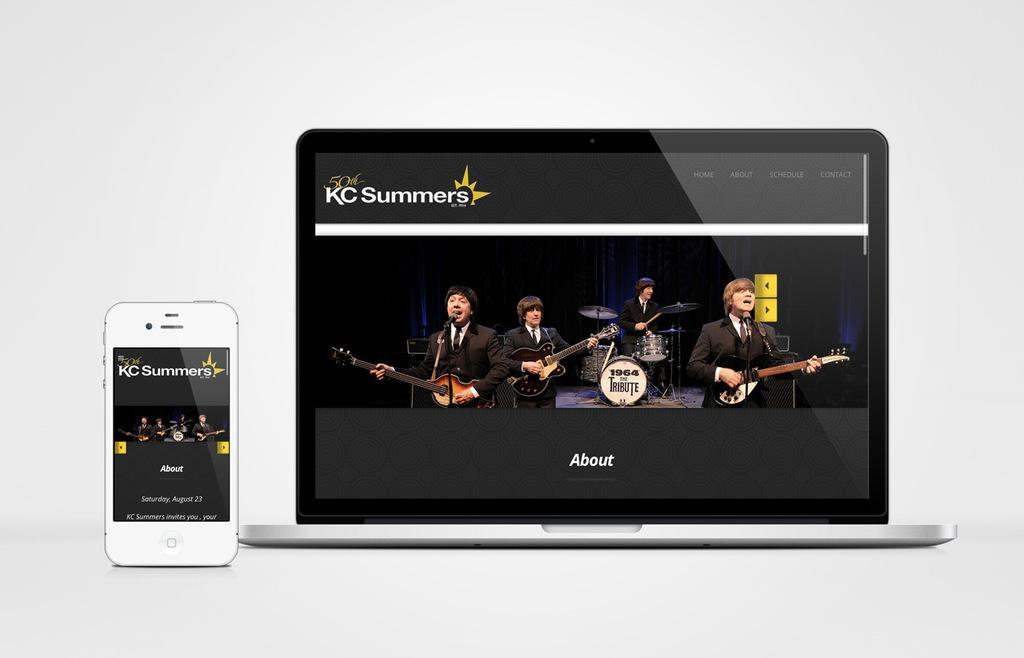What is kc's last name?
Make the answer very short. Summers. Is the phone and computer compatible?
Provide a short and direct response. Yes. 